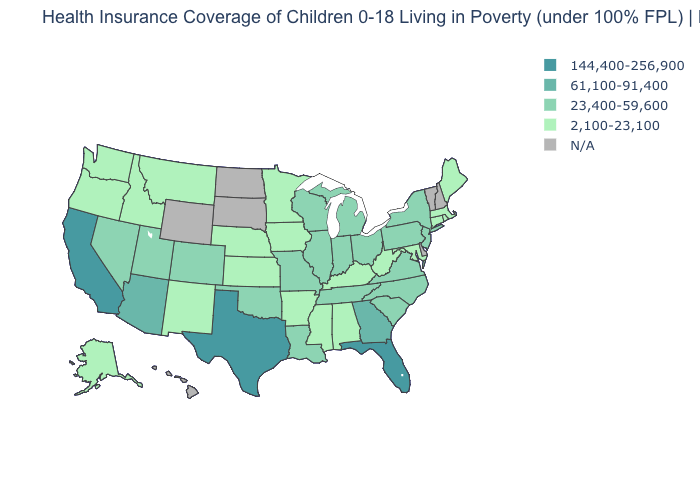How many symbols are there in the legend?
Answer briefly. 5. What is the value of Massachusetts?
Keep it brief. 2,100-23,100. Name the states that have a value in the range 2,100-23,100?
Short answer required. Alabama, Alaska, Arkansas, Connecticut, Idaho, Iowa, Kansas, Kentucky, Maine, Maryland, Massachusetts, Minnesota, Mississippi, Montana, Nebraska, New Mexico, Oregon, Rhode Island, Washington, West Virginia. What is the value of Connecticut?
Short answer required. 2,100-23,100. Among the states that border Tennessee , does Georgia have the highest value?
Short answer required. Yes. What is the lowest value in the USA?
Quick response, please. 2,100-23,100. Does Kansas have the highest value in the MidWest?
Give a very brief answer. No. What is the value of Hawaii?
Be succinct. N/A. Does Connecticut have the lowest value in the USA?
Answer briefly. Yes. Name the states that have a value in the range 61,100-91,400?
Short answer required. Arizona, Georgia. How many symbols are there in the legend?
Be succinct. 5. 